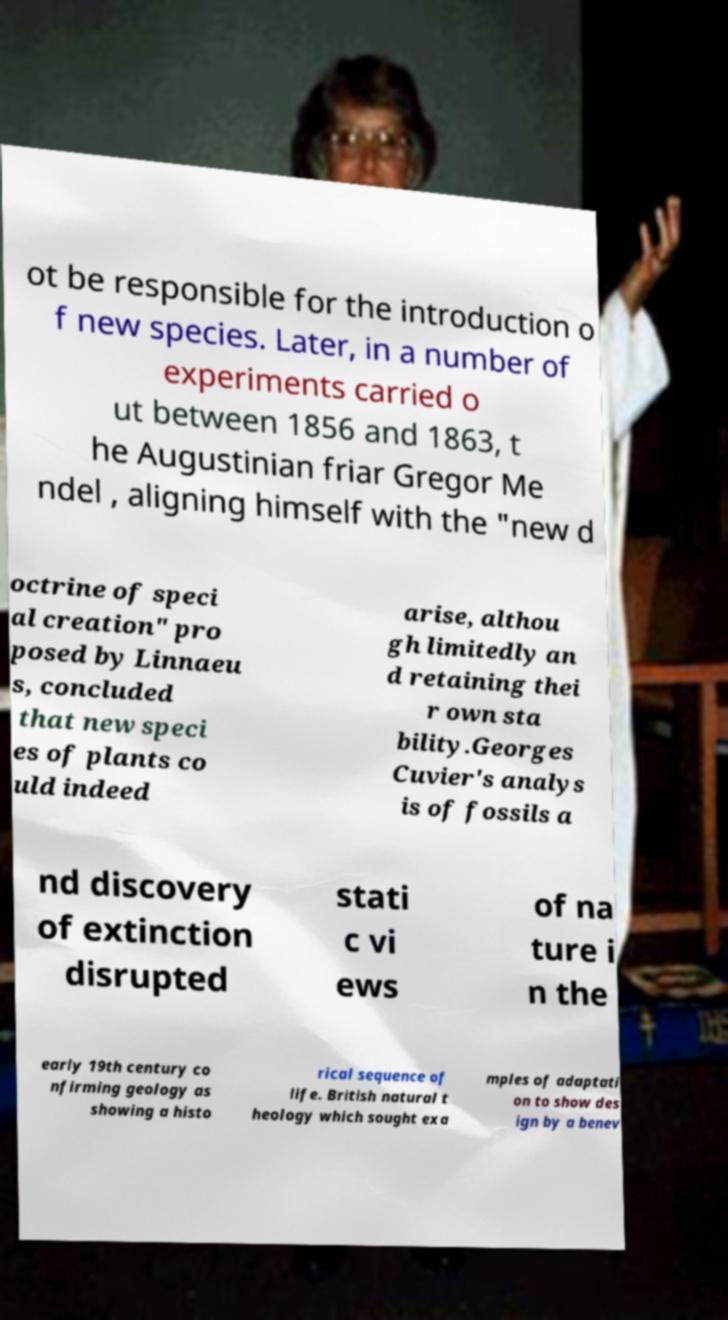Can you accurately transcribe the text from the provided image for me? ot be responsible for the introduction o f new species. Later, in a number of experiments carried o ut between 1856 and 1863, t he Augustinian friar Gregor Me ndel , aligning himself with the "new d octrine of speci al creation" pro posed by Linnaeu s, concluded that new speci es of plants co uld indeed arise, althou gh limitedly an d retaining thei r own sta bility.Georges Cuvier's analys is of fossils a nd discovery of extinction disrupted stati c vi ews of na ture i n the early 19th century co nfirming geology as showing a histo rical sequence of life. British natural t heology which sought exa mples of adaptati on to show des ign by a benev 